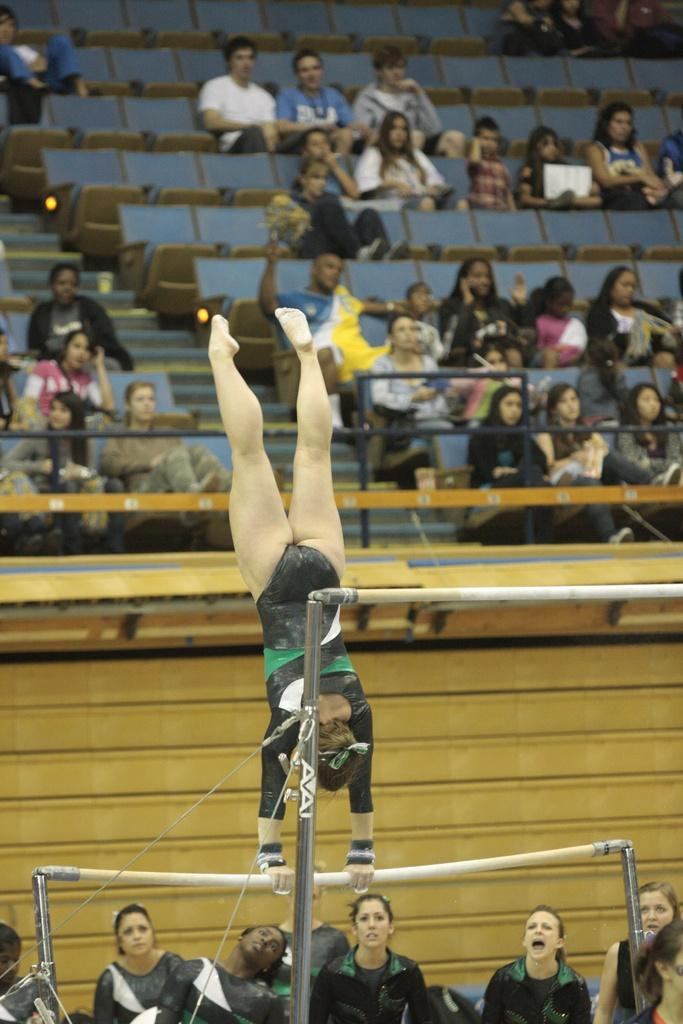Provide a one-sentence caption for the provided image. A gymnast performing on AVAI branded uneven bars in front of a crowd. 